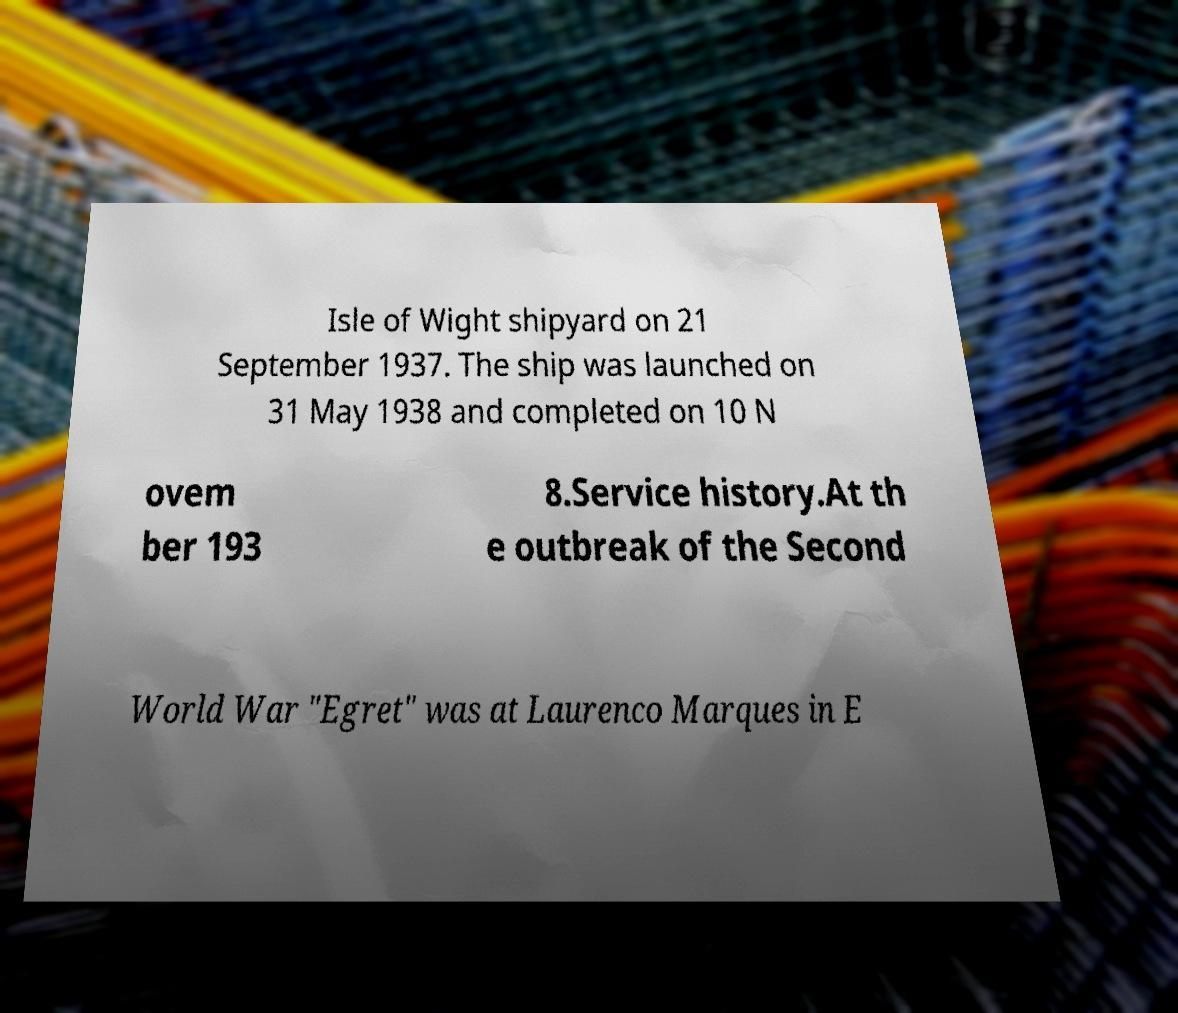Can you read and provide the text displayed in the image?This photo seems to have some interesting text. Can you extract and type it out for me? Isle of Wight shipyard on 21 September 1937. The ship was launched on 31 May 1938 and completed on 10 N ovem ber 193 8.Service history.At th e outbreak of the Second World War "Egret" was at Laurenco Marques in E 